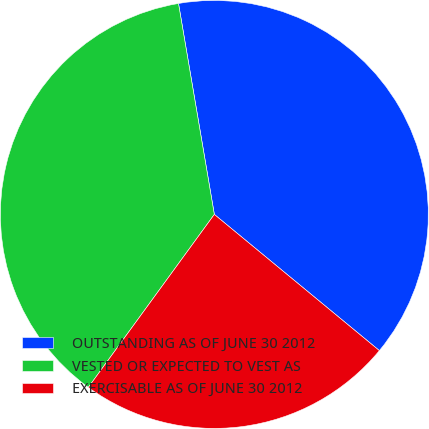Convert chart. <chart><loc_0><loc_0><loc_500><loc_500><pie_chart><fcel>OUTSTANDING AS OF JUNE 30 2012<fcel>VESTED OR EXPECTED TO VEST AS<fcel>EXERCISABLE AS OF JUNE 30 2012<nl><fcel>38.66%<fcel>37.3%<fcel>24.04%<nl></chart> 